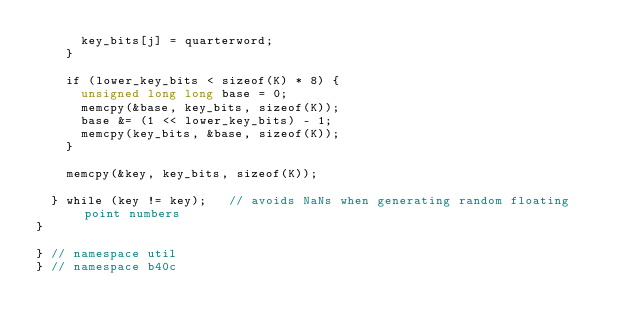Convert code to text. <code><loc_0><loc_0><loc_500><loc_500><_Cuda_>			key_bits[j] = quarterword;
		}
		
		if (lower_key_bits < sizeof(K) * 8) {
			unsigned long long base = 0;
			memcpy(&base, key_bits, sizeof(K));
			base &= (1 << lower_key_bits) - 1;
			memcpy(key_bits, &base, sizeof(K));
		}
		
		memcpy(&key, key_bits, sizeof(K));
		
	} while (key != key);		// avoids NaNs when generating random floating point numbers 
}

} // namespace util
} // namespace b40c
</code> 